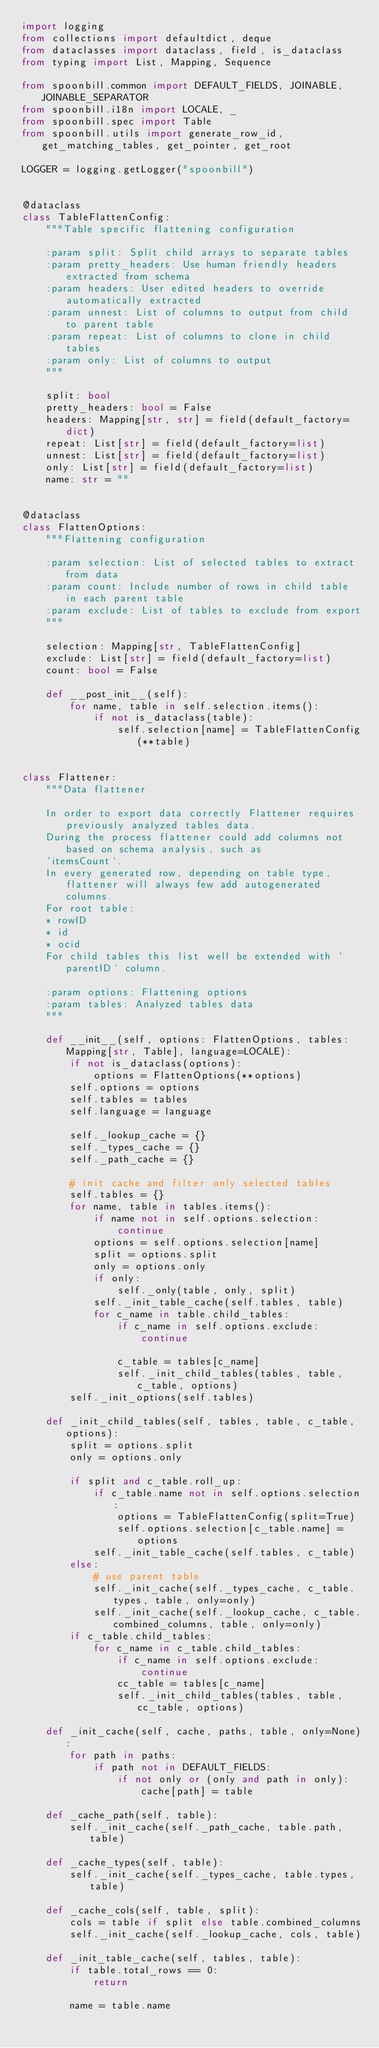Convert code to text. <code><loc_0><loc_0><loc_500><loc_500><_Python_>import logging
from collections import defaultdict, deque
from dataclasses import dataclass, field, is_dataclass
from typing import List, Mapping, Sequence

from spoonbill.common import DEFAULT_FIELDS, JOINABLE, JOINABLE_SEPARATOR
from spoonbill.i18n import LOCALE, _
from spoonbill.spec import Table
from spoonbill.utils import generate_row_id, get_matching_tables, get_pointer, get_root

LOGGER = logging.getLogger("spoonbill")


@dataclass
class TableFlattenConfig:
    """Table specific flattening configuration

    :param split: Split child arrays to separate tables
    :param pretty_headers: Use human friendly headers extracted from schema
    :param headers: User edited headers to override automatically extracted
    :param unnest: List of columns to output from child to parent table
    :param repeat: List of columns to clone in child tables
    :param only: List of columns to output
    """

    split: bool
    pretty_headers: bool = False
    headers: Mapping[str, str] = field(default_factory=dict)
    repeat: List[str] = field(default_factory=list)
    unnest: List[str] = field(default_factory=list)
    only: List[str] = field(default_factory=list)
    name: str = ""


@dataclass
class FlattenOptions:
    """Flattening configuration

    :param selection: List of selected tables to extract from data
    :param count: Include number of rows in child table in each parent table
    :param exclude: List of tables to exclude from export
    """

    selection: Mapping[str, TableFlattenConfig]
    exclude: List[str] = field(default_factory=list)
    count: bool = False

    def __post_init__(self):
        for name, table in self.selection.items():
            if not is_dataclass(table):
                self.selection[name] = TableFlattenConfig(**table)


class Flattener:
    """Data flattener

    In order to export data correctly Flattener requires previously analyzed tables data.
    During the process flattener could add columns not based on schema analysis, such as
    `itemsCount`.
    In every generated row, depending on table type, flattener will always few add autogenerated columns.
    For root table:
    * rowID
    * id
    * ocid
    For child tables this list well be extended with `parentID` column.

    :param options: Flattening options
    :param tables: Analyzed tables data
    """

    def __init__(self, options: FlattenOptions, tables: Mapping[str, Table], language=LOCALE):
        if not is_dataclass(options):
            options = FlattenOptions(**options)
        self.options = options
        self.tables = tables
        self.language = language

        self._lookup_cache = {}
        self._types_cache = {}
        self._path_cache = {}

        # init cache and filter only selected tables
        self.tables = {}
        for name, table in tables.items():
            if name not in self.options.selection:
                continue
            options = self.options.selection[name]
            split = options.split
            only = options.only
            if only:
                self._only(table, only, split)
            self._init_table_cache(self.tables, table)
            for c_name in table.child_tables:
                if c_name in self.options.exclude:
                    continue

                c_table = tables[c_name]
                self._init_child_tables(tables, table, c_table, options)
        self._init_options(self.tables)

    def _init_child_tables(self, tables, table, c_table, options):
        split = options.split
        only = options.only

        if split and c_table.roll_up:
            if c_table.name not in self.options.selection:
                options = TableFlattenConfig(split=True)
                self.options.selection[c_table.name] = options
            self._init_table_cache(self.tables, c_table)
        else:
            # use parent table
            self._init_cache(self._types_cache, c_table.types, table, only=only)
            self._init_cache(self._lookup_cache, c_table.combined_columns, table, only=only)
        if c_table.child_tables:
            for c_name in c_table.child_tables:
                if c_name in self.options.exclude:
                    continue
                cc_table = tables[c_name]
                self._init_child_tables(tables, table, cc_table, options)

    def _init_cache(self, cache, paths, table, only=None):
        for path in paths:
            if path not in DEFAULT_FIELDS:
                if not only or (only and path in only):
                    cache[path] = table

    def _cache_path(self, table):
        self._init_cache(self._path_cache, table.path, table)

    def _cache_types(self, table):
        self._init_cache(self._types_cache, table.types, table)

    def _cache_cols(self, table, split):
        cols = table if split else table.combined_columns
        self._init_cache(self._lookup_cache, cols, table)

    def _init_table_cache(self, tables, table):
        if table.total_rows == 0:
            return

        name = table.name</code> 